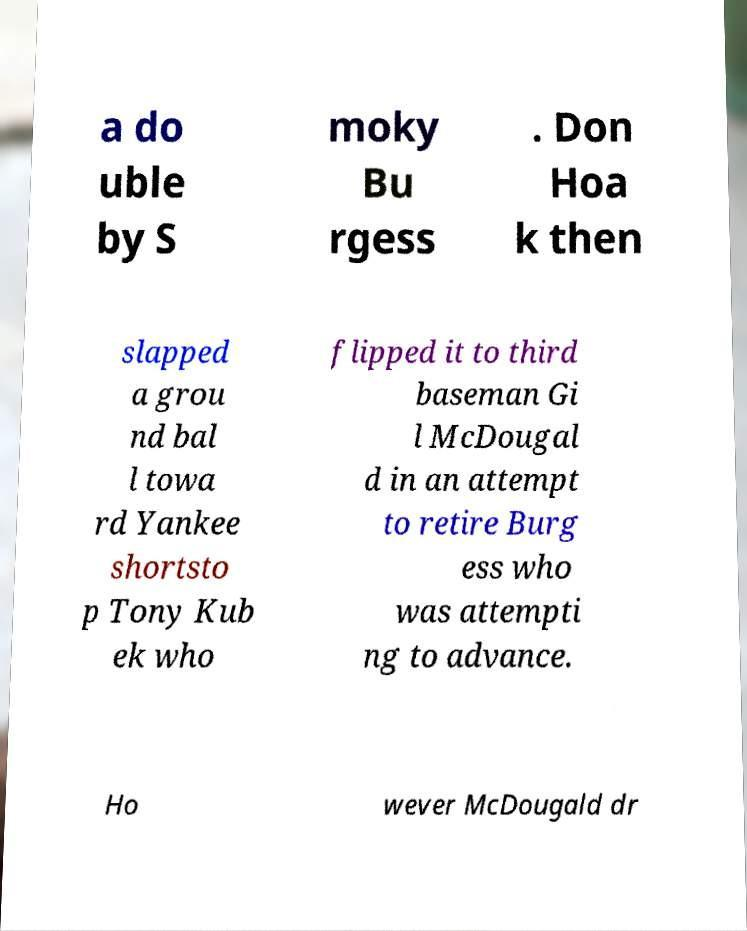I need the written content from this picture converted into text. Can you do that? a do uble by S moky Bu rgess . Don Hoa k then slapped a grou nd bal l towa rd Yankee shortsto p Tony Kub ek who flipped it to third baseman Gi l McDougal d in an attempt to retire Burg ess who was attempti ng to advance. Ho wever McDougald dr 